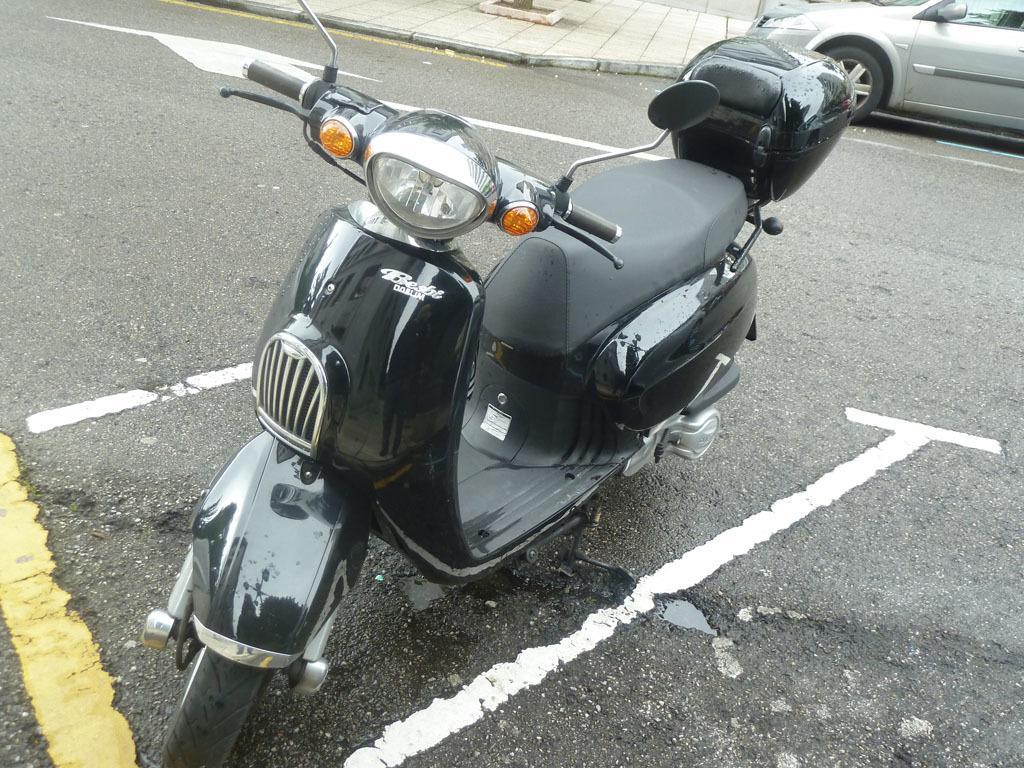Please provide a concise description of this image. In this picture we can see a black color scooter in the front, we can see a car at the right top of the picture, at the bottom there is road. 